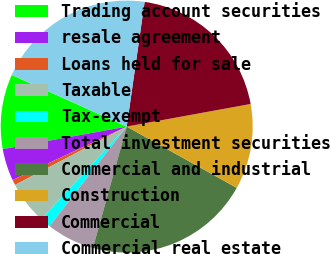Convert chart to OTSL. <chart><loc_0><loc_0><loc_500><loc_500><pie_chart><fcel>Trading account securities<fcel>resale agreement<fcel>Loans held for sale<fcel>Taxable<fcel>Tax-exempt<fcel>Total investment securities<fcel>Commercial and industrial<fcel>Construction<fcel>Commercial<fcel>Commercial real estate<nl><fcel>9.59%<fcel>4.11%<fcel>0.69%<fcel>5.48%<fcel>1.37%<fcel>6.17%<fcel>21.23%<fcel>10.96%<fcel>19.86%<fcel>20.55%<nl></chart> 